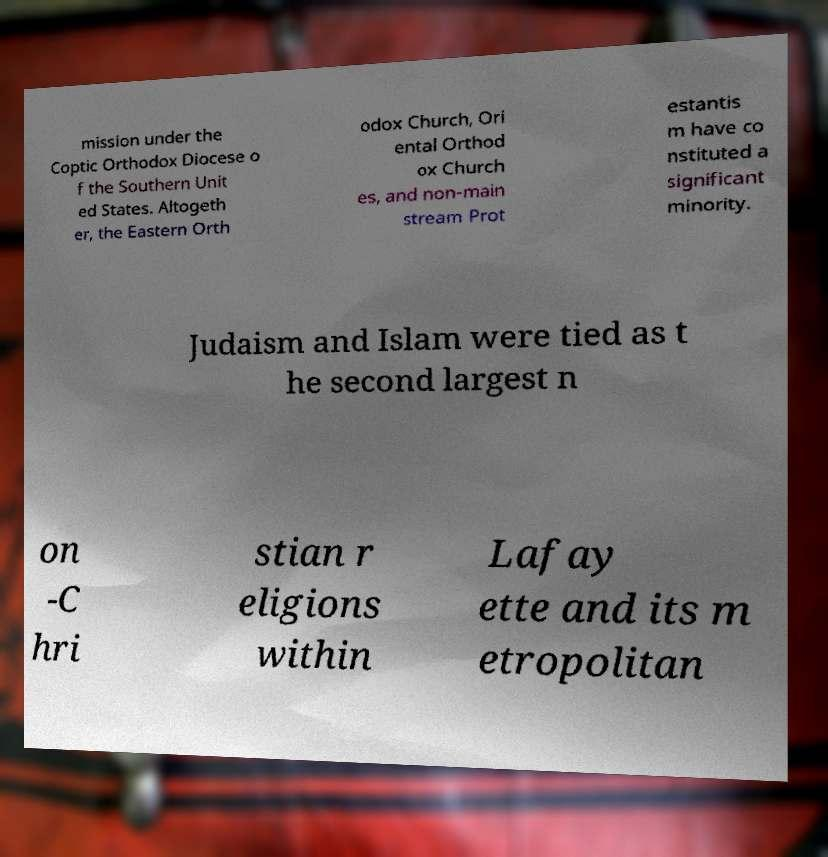What messages or text are displayed in this image? I need them in a readable, typed format. mission under the Coptic Orthodox Diocese o f the Southern Unit ed States. Altogeth er, the Eastern Orth odox Church, Ori ental Orthod ox Church es, and non-main stream Prot estantis m have co nstituted a significant minority. Judaism and Islam were tied as t he second largest n on -C hri stian r eligions within Lafay ette and its m etropolitan 